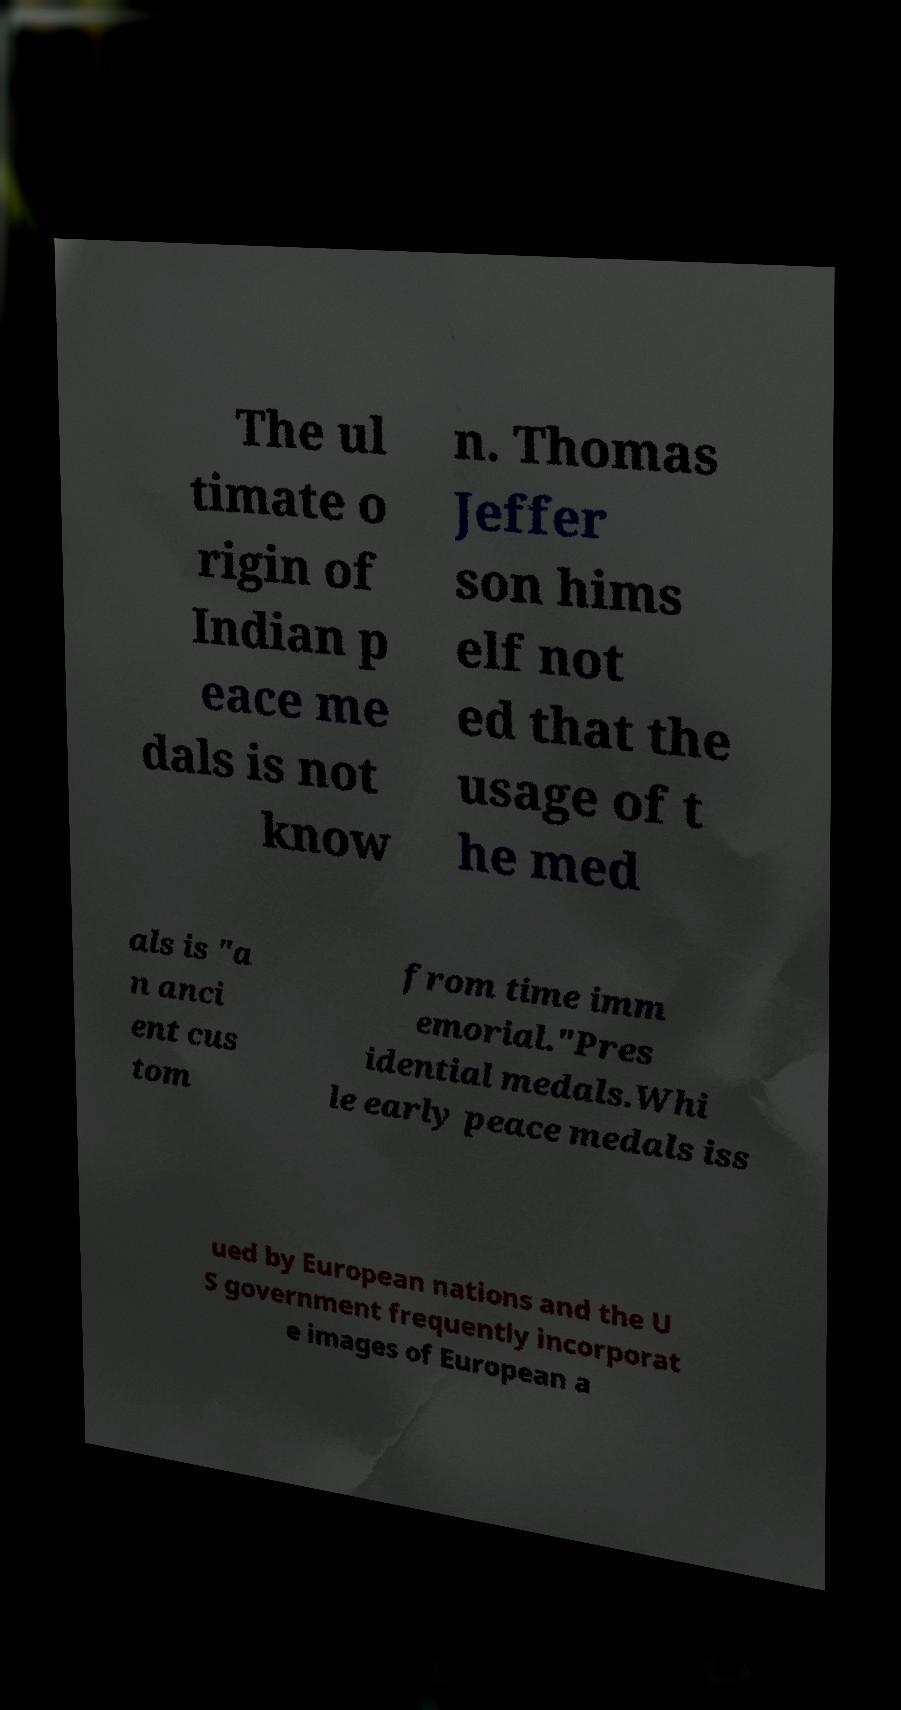What messages or text are displayed in this image? I need them in a readable, typed format. The ul timate o rigin of Indian p eace me dals is not know n. Thomas Jeffer son hims elf not ed that the usage of t he med als is "a n anci ent cus tom from time imm emorial."Pres idential medals.Whi le early peace medals iss ued by European nations and the U S government frequently incorporat e images of European a 